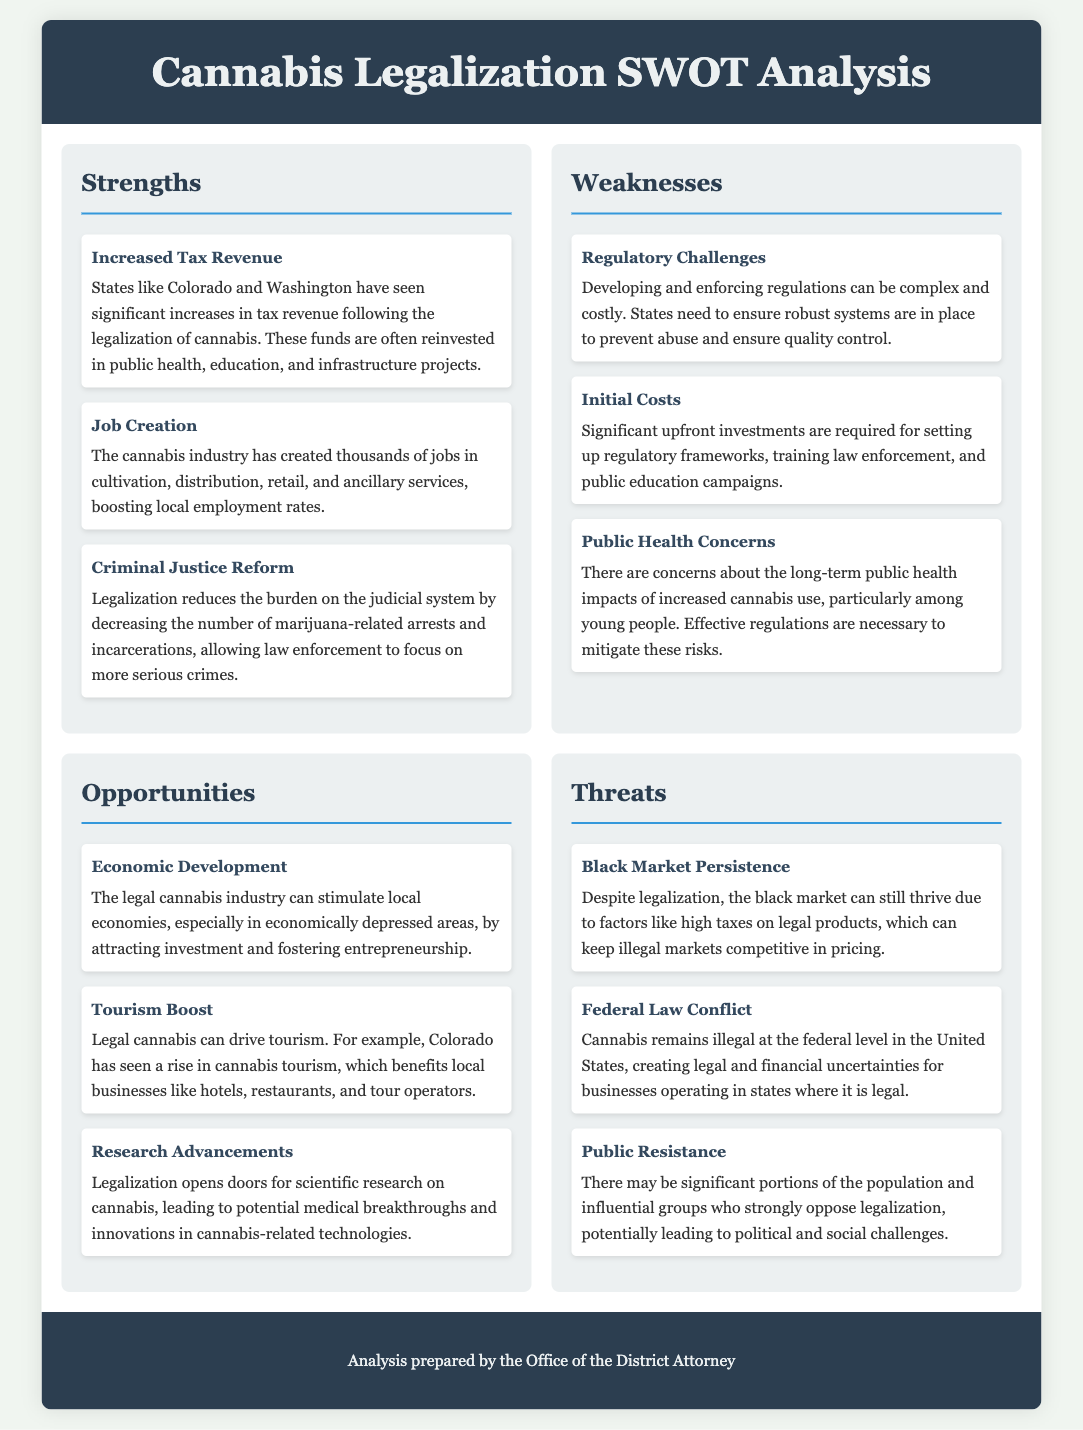what are the strengths of cannabis legalization? The strengths listed in the document include increased tax revenue, job creation, and criminal justice reform.
Answer: increased tax revenue, job creation, criminal justice reform what opportunity can stimulate local economies? The document mentions that the legal cannabis industry can stimulate local economies.
Answer: economic development what is a public health concern related to cannabis legalization? The document indicates that there are concerns about the long-term public health impacts of increased cannabis use, especially among young people.
Answer: public health impacts how many weaknesses are listed in the document? The document lists three weaknesses related to cannabis legalization.
Answer: three what threat relates to illegal cannabis sales? The document states that despite legalization, the black market can still thrive due to high taxes.
Answer: black market persistence what state is mentioned as having seen significant increases in tax revenue? The document references Colorado and Washington as states seeing significant increases.
Answer: Colorado and Washington what can legalization drive according to the document? The document notes that legal cannabis can drive tourism, benefiting local businesses.
Answer: tourism what is one of the regulatory challenges mentioned? A regulatory challenge listed in the document includes the complexity and cost of developing regulations.
Answer: regulatory challenges 